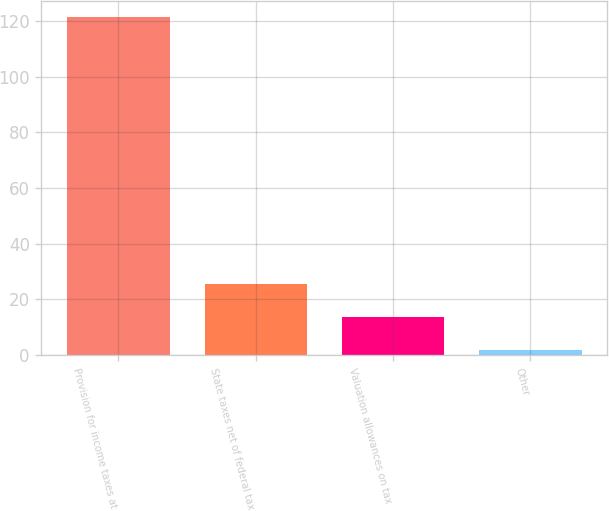Convert chart. <chart><loc_0><loc_0><loc_500><loc_500><bar_chart><fcel>Provision for income taxes at<fcel>State taxes net of federal tax<fcel>Valuation allowances on tax<fcel>Other<nl><fcel>121.2<fcel>25.68<fcel>13.74<fcel>1.8<nl></chart> 